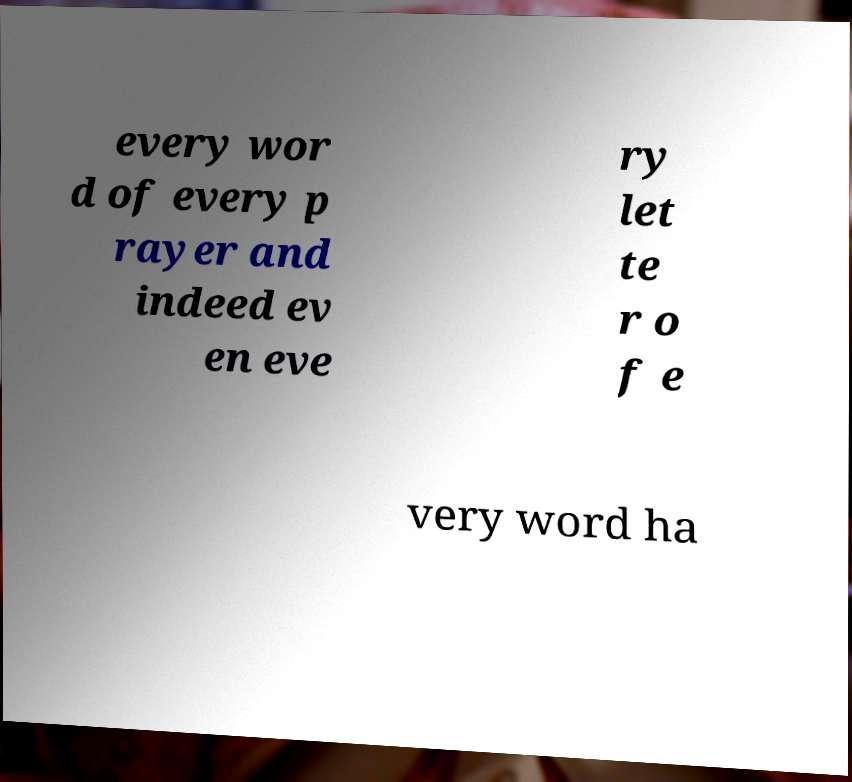Please read and relay the text visible in this image. What does it say? every wor d of every p rayer and indeed ev en eve ry let te r o f e very word ha 